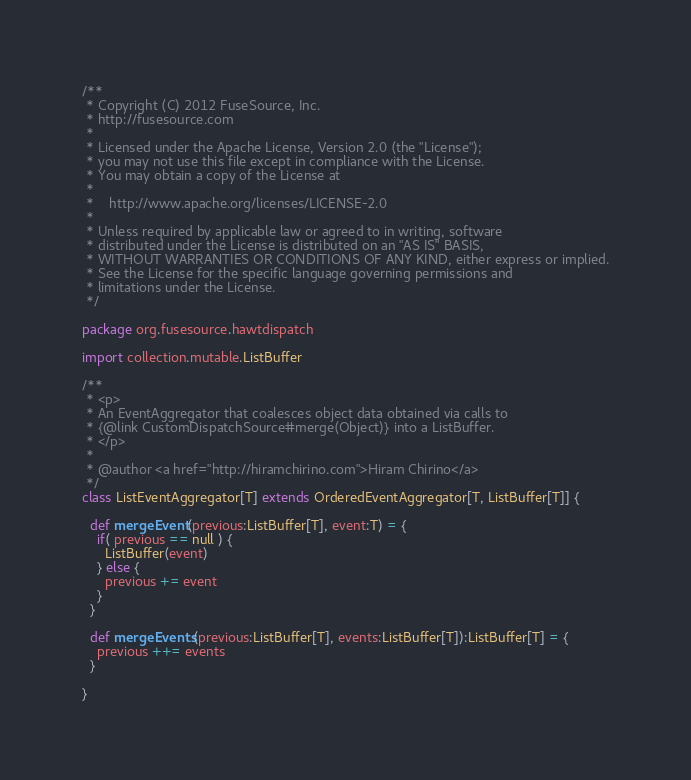<code> <loc_0><loc_0><loc_500><loc_500><_Scala_>/**
 * Copyright (C) 2012 FuseSource, Inc.
 * http://fusesource.com
 *
 * Licensed under the Apache License, Version 2.0 (the "License");
 * you may not use this file except in compliance with the License.
 * You may obtain a copy of the License at
 *
 *    http://www.apache.org/licenses/LICENSE-2.0
 *
 * Unless required by applicable law or agreed to in writing, software
 * distributed under the License is distributed on an "AS IS" BASIS,
 * WITHOUT WARRANTIES OR CONDITIONS OF ANY KIND, either express or implied.
 * See the License for the specific language governing permissions and
 * limitations under the License.
 */

package org.fusesource.hawtdispatch

import collection.mutable.ListBuffer

/**
 * <p>
 * An EventAggregator that coalesces object data obtained via calls to
 * {@link CustomDispatchSource#merge(Object)} into a ListBuffer.
 * </p>
 *
 * @author <a href="http://hiramchirino.com">Hiram Chirino</a>
 */
class ListEventAggregator[T] extends OrderedEventAggregator[T, ListBuffer[T]] {

  def mergeEvent(previous:ListBuffer[T], event:T) = {
    if( previous == null ) {
      ListBuffer(event)
    } else {
      previous += event
    }
  }

  def mergeEvents(previous:ListBuffer[T], events:ListBuffer[T]):ListBuffer[T] = {
    previous ++= events
  }
  
}
</code> 